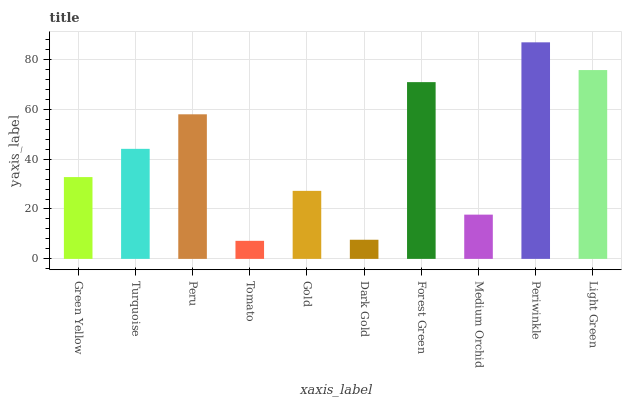Is Tomato the minimum?
Answer yes or no. Yes. Is Periwinkle the maximum?
Answer yes or no. Yes. Is Turquoise the minimum?
Answer yes or no. No. Is Turquoise the maximum?
Answer yes or no. No. Is Turquoise greater than Green Yellow?
Answer yes or no. Yes. Is Green Yellow less than Turquoise?
Answer yes or no. Yes. Is Green Yellow greater than Turquoise?
Answer yes or no. No. Is Turquoise less than Green Yellow?
Answer yes or no. No. Is Turquoise the high median?
Answer yes or no. Yes. Is Green Yellow the low median?
Answer yes or no. Yes. Is Gold the high median?
Answer yes or no. No. Is Turquoise the low median?
Answer yes or no. No. 